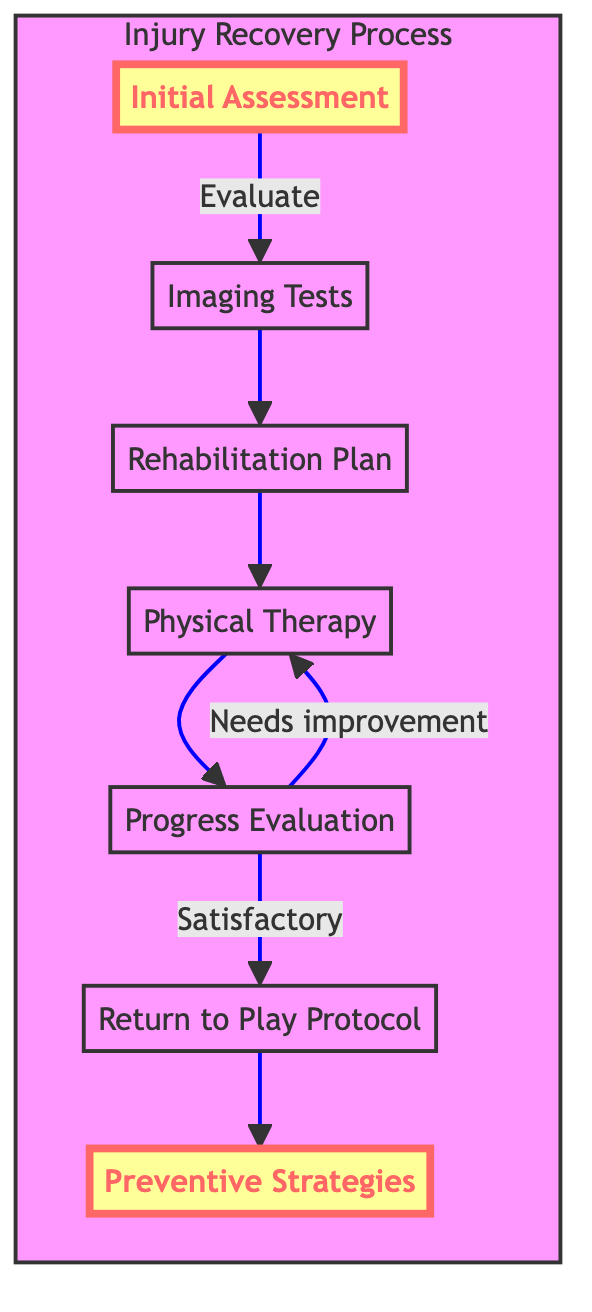What is the first step in the recovery process? The diagram starts with the "Initial Assessment" as the first step in the injury recovery process.
Answer: Initial Assessment How many steps are outlined in the injury recovery process? There are seven steps represented in the diagram: Initial Assessment, Imaging Tests, Rehabilitation Plan, Physical Therapy, Progress Evaluation, Return to Play Protocol, and Preventive Strategies.
Answer: Seven What is evaluated after Physical Therapy? After Physical Therapy, the "Progress Evaluation" is performed to check recovery progress.
Answer: Progress Evaluation What happens if the Progress Evaluation is satisfactory? If the Progress Evaluation is satisfactory, the next step is the "Return to Play Protocol" where the athlete begins reintegration into practice and competition.
Answer: Return to Play Protocol What leads to Preventive Strategies? The "Return to Play Protocol" leads to the implementation of "Preventive Strategies" aimed at avoiding future injuries.
Answer: Preventive Strategies Which step comes after Imaging Tests? The step that comes after Imaging Tests is the "Rehabilitation Plan," where a personalized recovery program is created.
Answer: Rehabilitation Plan What condition leads back to Physical Therapy? If the Progress Evaluation indicates "Needs improvement," the flow goes back to "Physical Therapy" for further exercises and recovery efforts.
Answer: Needs improvement In how many directions can the flow move from the Progress Evaluation? From the Progress Evaluation, the flow can move in two directions: to the "Return to Play Protocol" if satisfactory, or back to "Physical Therapy" if improvement is needed.
Answer: Two What node is highlighted in the diagram? The nodes "Initial Assessment" and "Preventive Strategies" are highlighted, indicating their importance in the process.
Answer: Initial Assessment and Preventive Strategies 